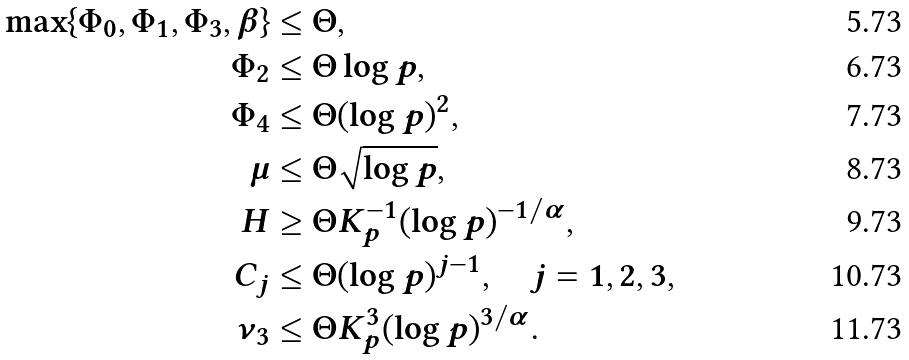Convert formula to latex. <formula><loc_0><loc_0><loc_500><loc_500>\max \{ \Phi _ { 0 } , \Phi _ { 1 } , \Phi _ { 3 } , \beta \} & \leq \Theta , \\ \Phi _ { 2 } & \leq \Theta \log p , \\ \Phi _ { 4 } & \leq \Theta ( \log p ) ^ { 2 } , \\ \mu & \leq \Theta \sqrt { \log p } , \\ H & \geq \Theta K _ { p } ^ { - 1 } ( \log p ) ^ { - 1 / \alpha } , \\ C _ { j } & \leq \Theta ( \log p ) ^ { j - 1 } , \quad j = 1 , 2 , 3 , \\ \nu _ { 3 } & \leq \Theta K _ { p } ^ { 3 } ( \log p ) ^ { 3 / \alpha } .</formula> 